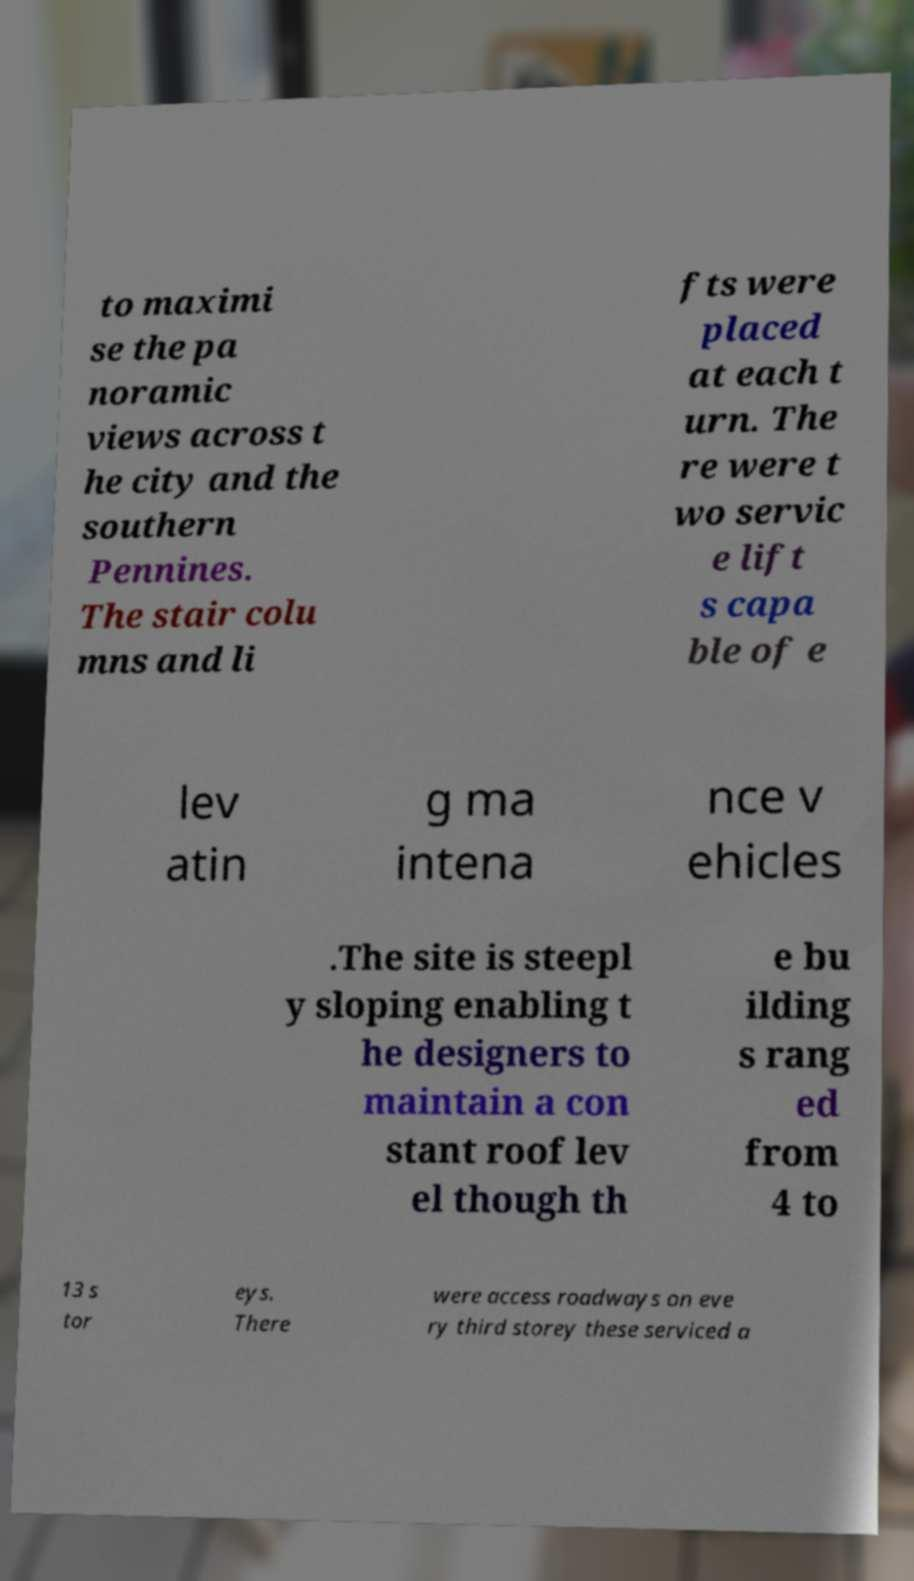Can you read and provide the text displayed in the image?This photo seems to have some interesting text. Can you extract and type it out for me? to maximi se the pa noramic views across t he city and the southern Pennines. The stair colu mns and li fts were placed at each t urn. The re were t wo servic e lift s capa ble of e lev atin g ma intena nce v ehicles .The site is steepl y sloping enabling t he designers to maintain a con stant roof lev el though th e bu ilding s rang ed from 4 to 13 s tor eys. There were access roadways on eve ry third storey these serviced a 